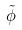<formula> <loc_0><loc_0><loc_500><loc_500>\tilde { \phi }</formula> 